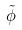<formula> <loc_0><loc_0><loc_500><loc_500>\tilde { \phi }</formula> 